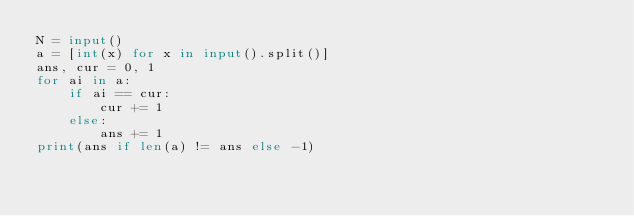<code> <loc_0><loc_0><loc_500><loc_500><_Python_>N = input()
a = [int(x) for x in input().split()]
ans, cur = 0, 1
for ai in a:
    if ai == cur:
        cur += 1
    else:
        ans += 1
print(ans if len(a) != ans else -1)
</code> 